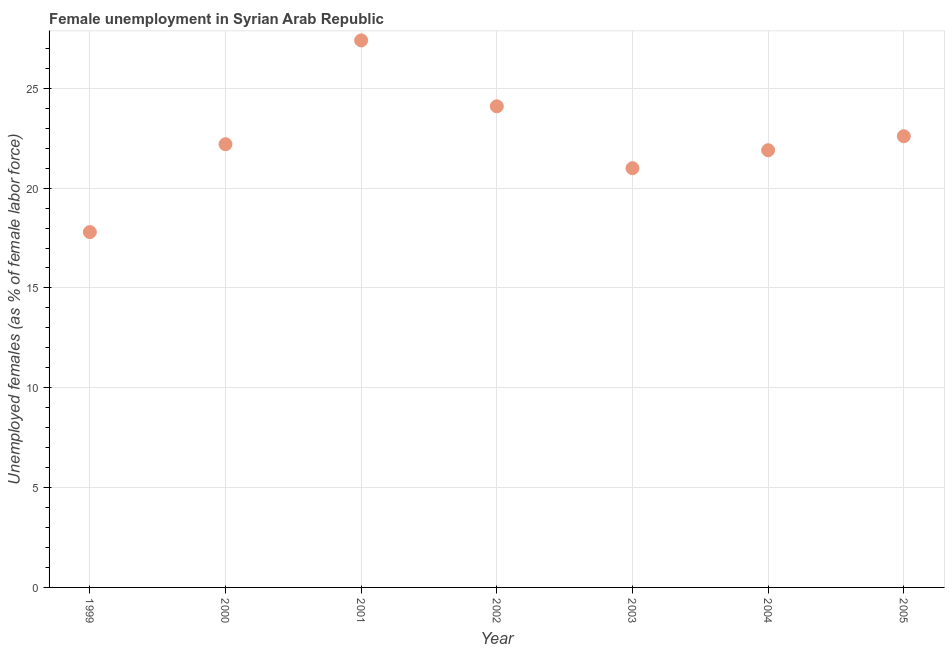What is the unemployed females population in 2005?
Provide a succinct answer. 22.6. Across all years, what is the maximum unemployed females population?
Offer a very short reply. 27.4. Across all years, what is the minimum unemployed females population?
Ensure brevity in your answer.  17.8. What is the sum of the unemployed females population?
Your answer should be very brief. 157. What is the difference between the unemployed females population in 1999 and 2004?
Keep it short and to the point. -4.1. What is the average unemployed females population per year?
Ensure brevity in your answer.  22.43. What is the median unemployed females population?
Your response must be concise. 22.2. Do a majority of the years between 1999 and 2002 (inclusive) have unemployed females population greater than 3 %?
Your answer should be compact. Yes. What is the ratio of the unemployed females population in 1999 to that in 2003?
Your answer should be compact. 0.85. Is the unemployed females population in 1999 less than that in 2004?
Make the answer very short. Yes. Is the difference between the unemployed females population in 2003 and 2005 greater than the difference between any two years?
Provide a short and direct response. No. What is the difference between the highest and the second highest unemployed females population?
Offer a very short reply. 3.3. What is the difference between the highest and the lowest unemployed females population?
Your answer should be very brief. 9.6. Does the unemployed females population monotonically increase over the years?
Your answer should be compact. No. What is the difference between two consecutive major ticks on the Y-axis?
Offer a very short reply. 5. Does the graph contain any zero values?
Your answer should be very brief. No. Does the graph contain grids?
Your answer should be very brief. Yes. What is the title of the graph?
Give a very brief answer. Female unemployment in Syrian Arab Republic. What is the label or title of the X-axis?
Make the answer very short. Year. What is the label or title of the Y-axis?
Your answer should be compact. Unemployed females (as % of female labor force). What is the Unemployed females (as % of female labor force) in 1999?
Give a very brief answer. 17.8. What is the Unemployed females (as % of female labor force) in 2000?
Provide a short and direct response. 22.2. What is the Unemployed females (as % of female labor force) in 2001?
Keep it short and to the point. 27.4. What is the Unemployed females (as % of female labor force) in 2002?
Your answer should be very brief. 24.1. What is the Unemployed females (as % of female labor force) in 2004?
Provide a succinct answer. 21.9. What is the Unemployed females (as % of female labor force) in 2005?
Keep it short and to the point. 22.6. What is the difference between the Unemployed females (as % of female labor force) in 1999 and 2000?
Your answer should be very brief. -4.4. What is the difference between the Unemployed females (as % of female labor force) in 1999 and 2001?
Your answer should be compact. -9.6. What is the difference between the Unemployed females (as % of female labor force) in 1999 and 2004?
Offer a very short reply. -4.1. What is the difference between the Unemployed females (as % of female labor force) in 1999 and 2005?
Ensure brevity in your answer.  -4.8. What is the difference between the Unemployed females (as % of female labor force) in 2000 and 2002?
Ensure brevity in your answer.  -1.9. What is the difference between the Unemployed females (as % of female labor force) in 2000 and 2003?
Offer a very short reply. 1.2. What is the difference between the Unemployed females (as % of female labor force) in 2000 and 2004?
Your response must be concise. 0.3. What is the difference between the Unemployed females (as % of female labor force) in 2000 and 2005?
Provide a succinct answer. -0.4. What is the difference between the Unemployed females (as % of female labor force) in 2001 and 2004?
Offer a very short reply. 5.5. What is the difference between the Unemployed females (as % of female labor force) in 2001 and 2005?
Provide a short and direct response. 4.8. What is the difference between the Unemployed females (as % of female labor force) in 2002 and 2004?
Provide a short and direct response. 2.2. What is the difference between the Unemployed females (as % of female labor force) in 2002 and 2005?
Keep it short and to the point. 1.5. What is the difference between the Unemployed females (as % of female labor force) in 2003 and 2005?
Provide a short and direct response. -1.6. What is the ratio of the Unemployed females (as % of female labor force) in 1999 to that in 2000?
Provide a short and direct response. 0.8. What is the ratio of the Unemployed females (as % of female labor force) in 1999 to that in 2001?
Keep it short and to the point. 0.65. What is the ratio of the Unemployed females (as % of female labor force) in 1999 to that in 2002?
Provide a succinct answer. 0.74. What is the ratio of the Unemployed females (as % of female labor force) in 1999 to that in 2003?
Make the answer very short. 0.85. What is the ratio of the Unemployed females (as % of female labor force) in 1999 to that in 2004?
Your answer should be very brief. 0.81. What is the ratio of the Unemployed females (as % of female labor force) in 1999 to that in 2005?
Your answer should be very brief. 0.79. What is the ratio of the Unemployed females (as % of female labor force) in 2000 to that in 2001?
Your response must be concise. 0.81. What is the ratio of the Unemployed females (as % of female labor force) in 2000 to that in 2002?
Provide a succinct answer. 0.92. What is the ratio of the Unemployed females (as % of female labor force) in 2000 to that in 2003?
Keep it short and to the point. 1.06. What is the ratio of the Unemployed females (as % of female labor force) in 2000 to that in 2005?
Ensure brevity in your answer.  0.98. What is the ratio of the Unemployed females (as % of female labor force) in 2001 to that in 2002?
Ensure brevity in your answer.  1.14. What is the ratio of the Unemployed females (as % of female labor force) in 2001 to that in 2003?
Offer a very short reply. 1.3. What is the ratio of the Unemployed females (as % of female labor force) in 2001 to that in 2004?
Provide a short and direct response. 1.25. What is the ratio of the Unemployed females (as % of female labor force) in 2001 to that in 2005?
Provide a succinct answer. 1.21. What is the ratio of the Unemployed females (as % of female labor force) in 2002 to that in 2003?
Offer a terse response. 1.15. What is the ratio of the Unemployed females (as % of female labor force) in 2002 to that in 2004?
Provide a succinct answer. 1.1. What is the ratio of the Unemployed females (as % of female labor force) in 2002 to that in 2005?
Offer a terse response. 1.07. What is the ratio of the Unemployed females (as % of female labor force) in 2003 to that in 2004?
Your answer should be compact. 0.96. What is the ratio of the Unemployed females (as % of female labor force) in 2003 to that in 2005?
Provide a succinct answer. 0.93. 